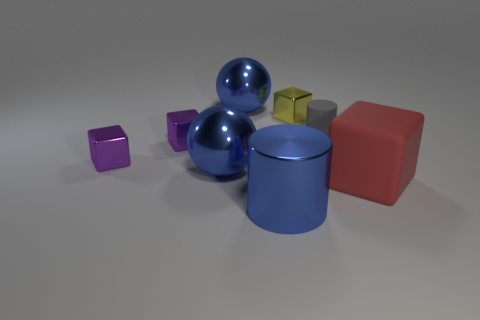Is the size of the yellow shiny cube the same as the red matte cube?
Your answer should be compact. No. Is the color of the big cylinder the same as the metal sphere in front of the small yellow metallic thing?
Provide a succinct answer. Yes. How many other things are there of the same color as the large cylinder?
Make the answer very short. 2. Is the number of small green metallic spheres less than the number of big cubes?
Provide a succinct answer. Yes. There is a big object that is right of the tiny cube that is to the right of the big blue metal cylinder; what number of big shiny objects are in front of it?
Your answer should be compact. 1. How big is the metallic sphere in front of the gray matte thing?
Provide a succinct answer. Large. There is a large object right of the blue cylinder; does it have the same shape as the yellow metal thing?
Your answer should be compact. Yes. There is a large red object that is the same shape as the small yellow thing; what is its material?
Provide a short and direct response. Rubber. Are there any tiny rubber cylinders?
Offer a terse response. Yes. What is the tiny object that is to the right of the tiny metallic cube that is to the right of the cylinder that is in front of the big red block made of?
Offer a terse response. Rubber. 